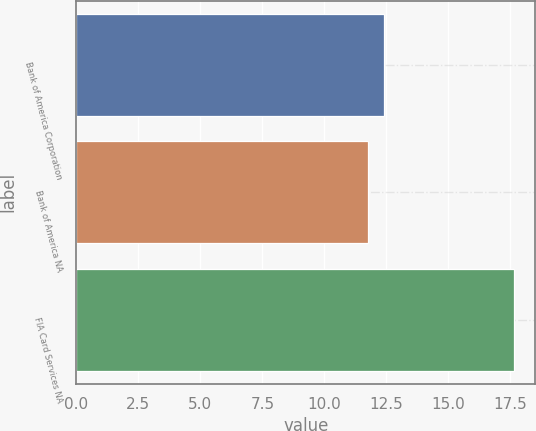Convert chart. <chart><loc_0><loc_0><loc_500><loc_500><bar_chart><fcel>Bank of America Corporation<fcel>Bank of America NA<fcel>FIA Card Services NA<nl><fcel>12.4<fcel>11.74<fcel>17.63<nl></chart> 